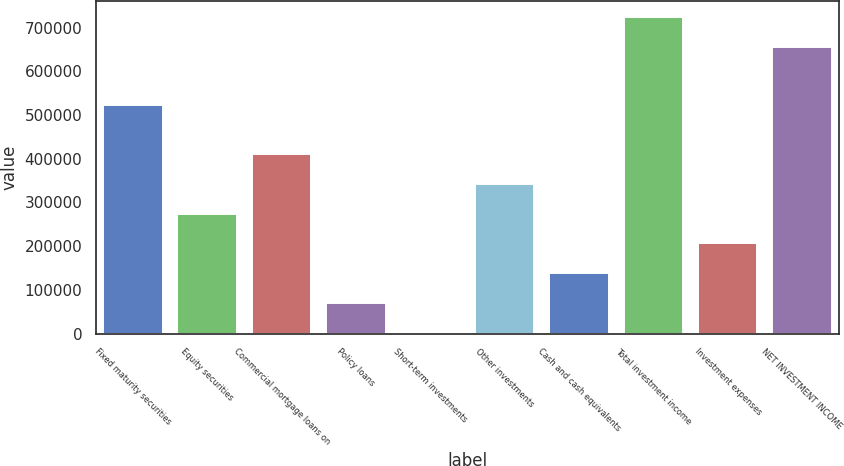Convert chart. <chart><loc_0><loc_0><loc_500><loc_500><bar_chart><fcel>Fixed maturity securities<fcel>Equity securities<fcel>Commercial mortgage loans on<fcel>Policy loans<fcel>Short-term investments<fcel>Other investments<fcel>Cash and cash equivalents<fcel>Total investment income<fcel>Investment expenses<fcel>NET INVESTMENT INCOME<nl><fcel>522309<fcel>274072<fcel>410132<fcel>69980.4<fcel>1950<fcel>342102<fcel>138011<fcel>724459<fcel>206041<fcel>656429<nl></chart> 